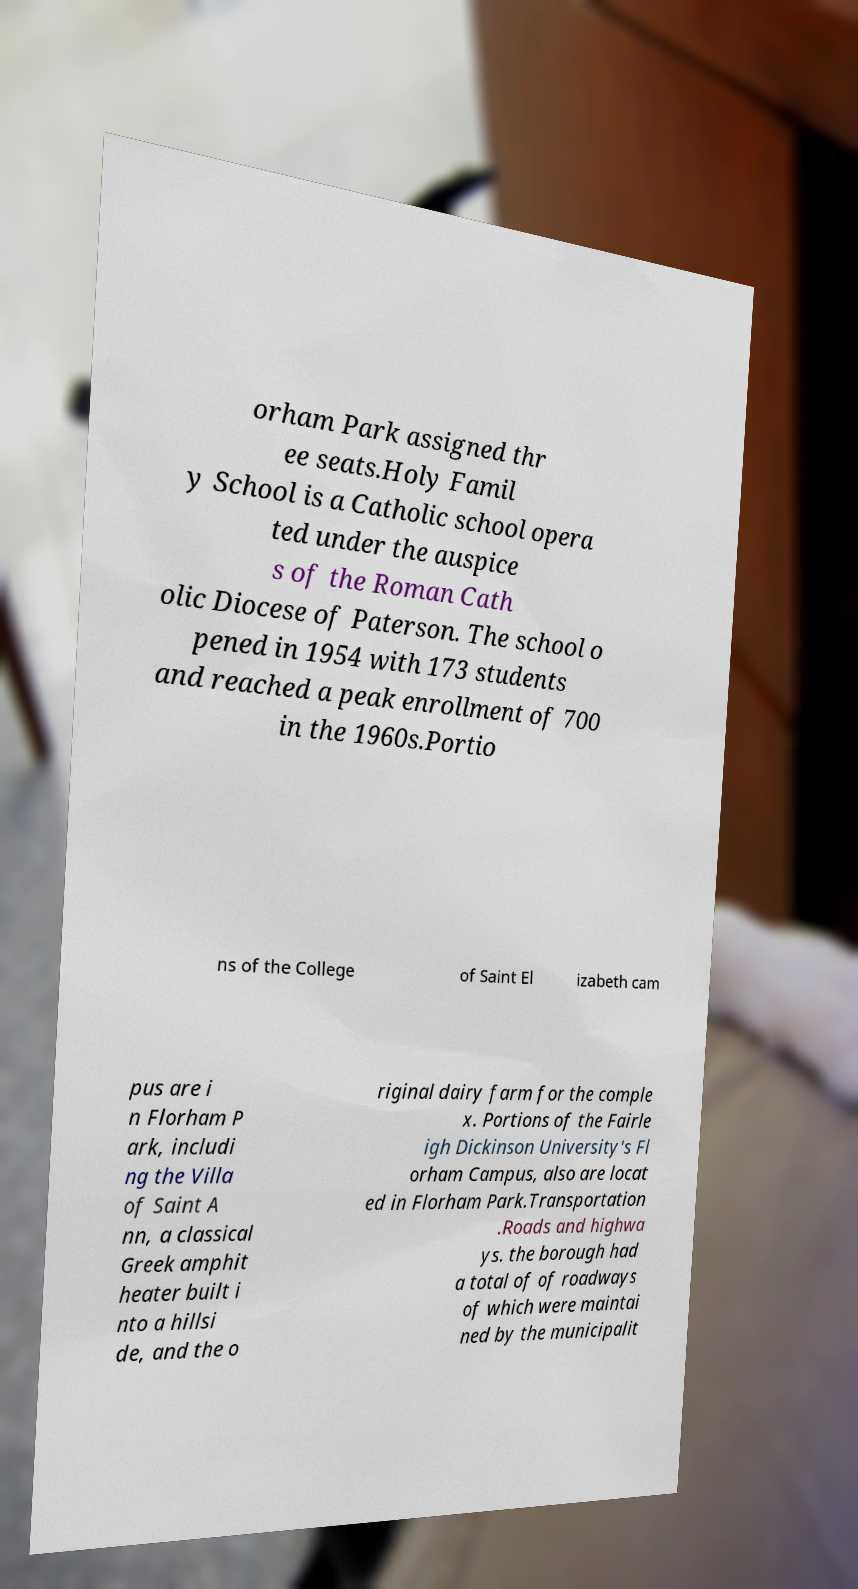Can you read and provide the text displayed in the image?This photo seems to have some interesting text. Can you extract and type it out for me? orham Park assigned thr ee seats.Holy Famil y School is a Catholic school opera ted under the auspice s of the Roman Cath olic Diocese of Paterson. The school o pened in 1954 with 173 students and reached a peak enrollment of 700 in the 1960s.Portio ns of the College of Saint El izabeth cam pus are i n Florham P ark, includi ng the Villa of Saint A nn, a classical Greek amphit heater built i nto a hillsi de, and the o riginal dairy farm for the comple x. Portions of the Fairle igh Dickinson University's Fl orham Campus, also are locat ed in Florham Park.Transportation .Roads and highwa ys. the borough had a total of of roadways of which were maintai ned by the municipalit 